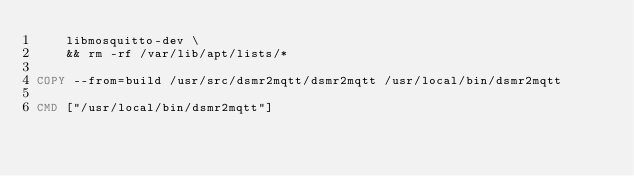Convert code to text. <code><loc_0><loc_0><loc_500><loc_500><_Dockerfile_>	libmosquitto-dev \
	&& rm -rf /var/lib/apt/lists/*

COPY --from=build /usr/src/dsmr2mqtt/dsmr2mqtt /usr/local/bin/dsmr2mqtt

CMD ["/usr/local/bin/dsmr2mqtt"]</code> 